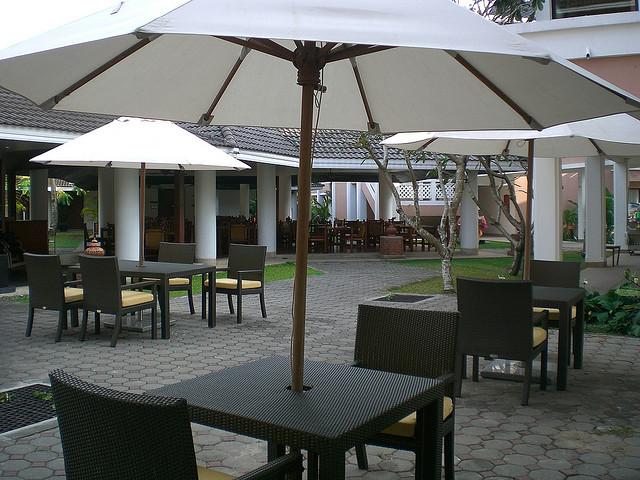What color are the chair cushions?
Answer briefly. Yellow. What color are the umbrellas?
Short answer required. White. Is the umbrella circular?
Concise answer only. Yes. What type of flooring is shown?
Short answer required. Tile. What location is this?
Keep it brief. Outside. Do you see any living animals in this photo?
Keep it brief. No. Is this outdoors?
Answer briefly. Yes. How many chairs at the 3 tables?
Answer briefly. 8. Is the Umbrella covering both tables?
Answer briefly. No. 